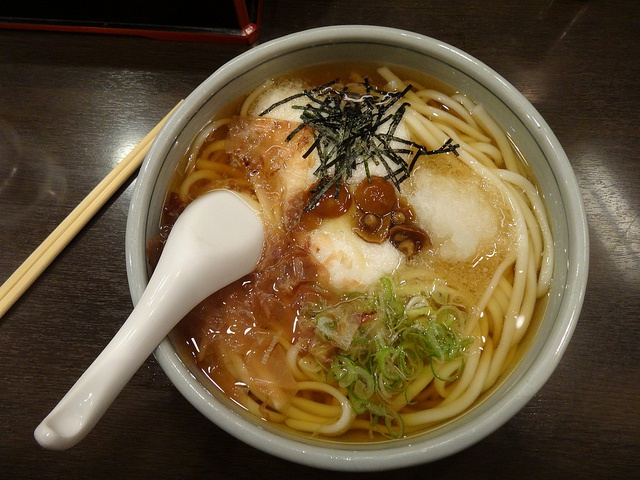Describe the objects in this image and their specific colors. I can see dining table in black, olive, maroon, and tan tones, bowl in black, olive, tan, and maroon tones, and spoon in black, lightgray, darkgray, and gray tones in this image. 